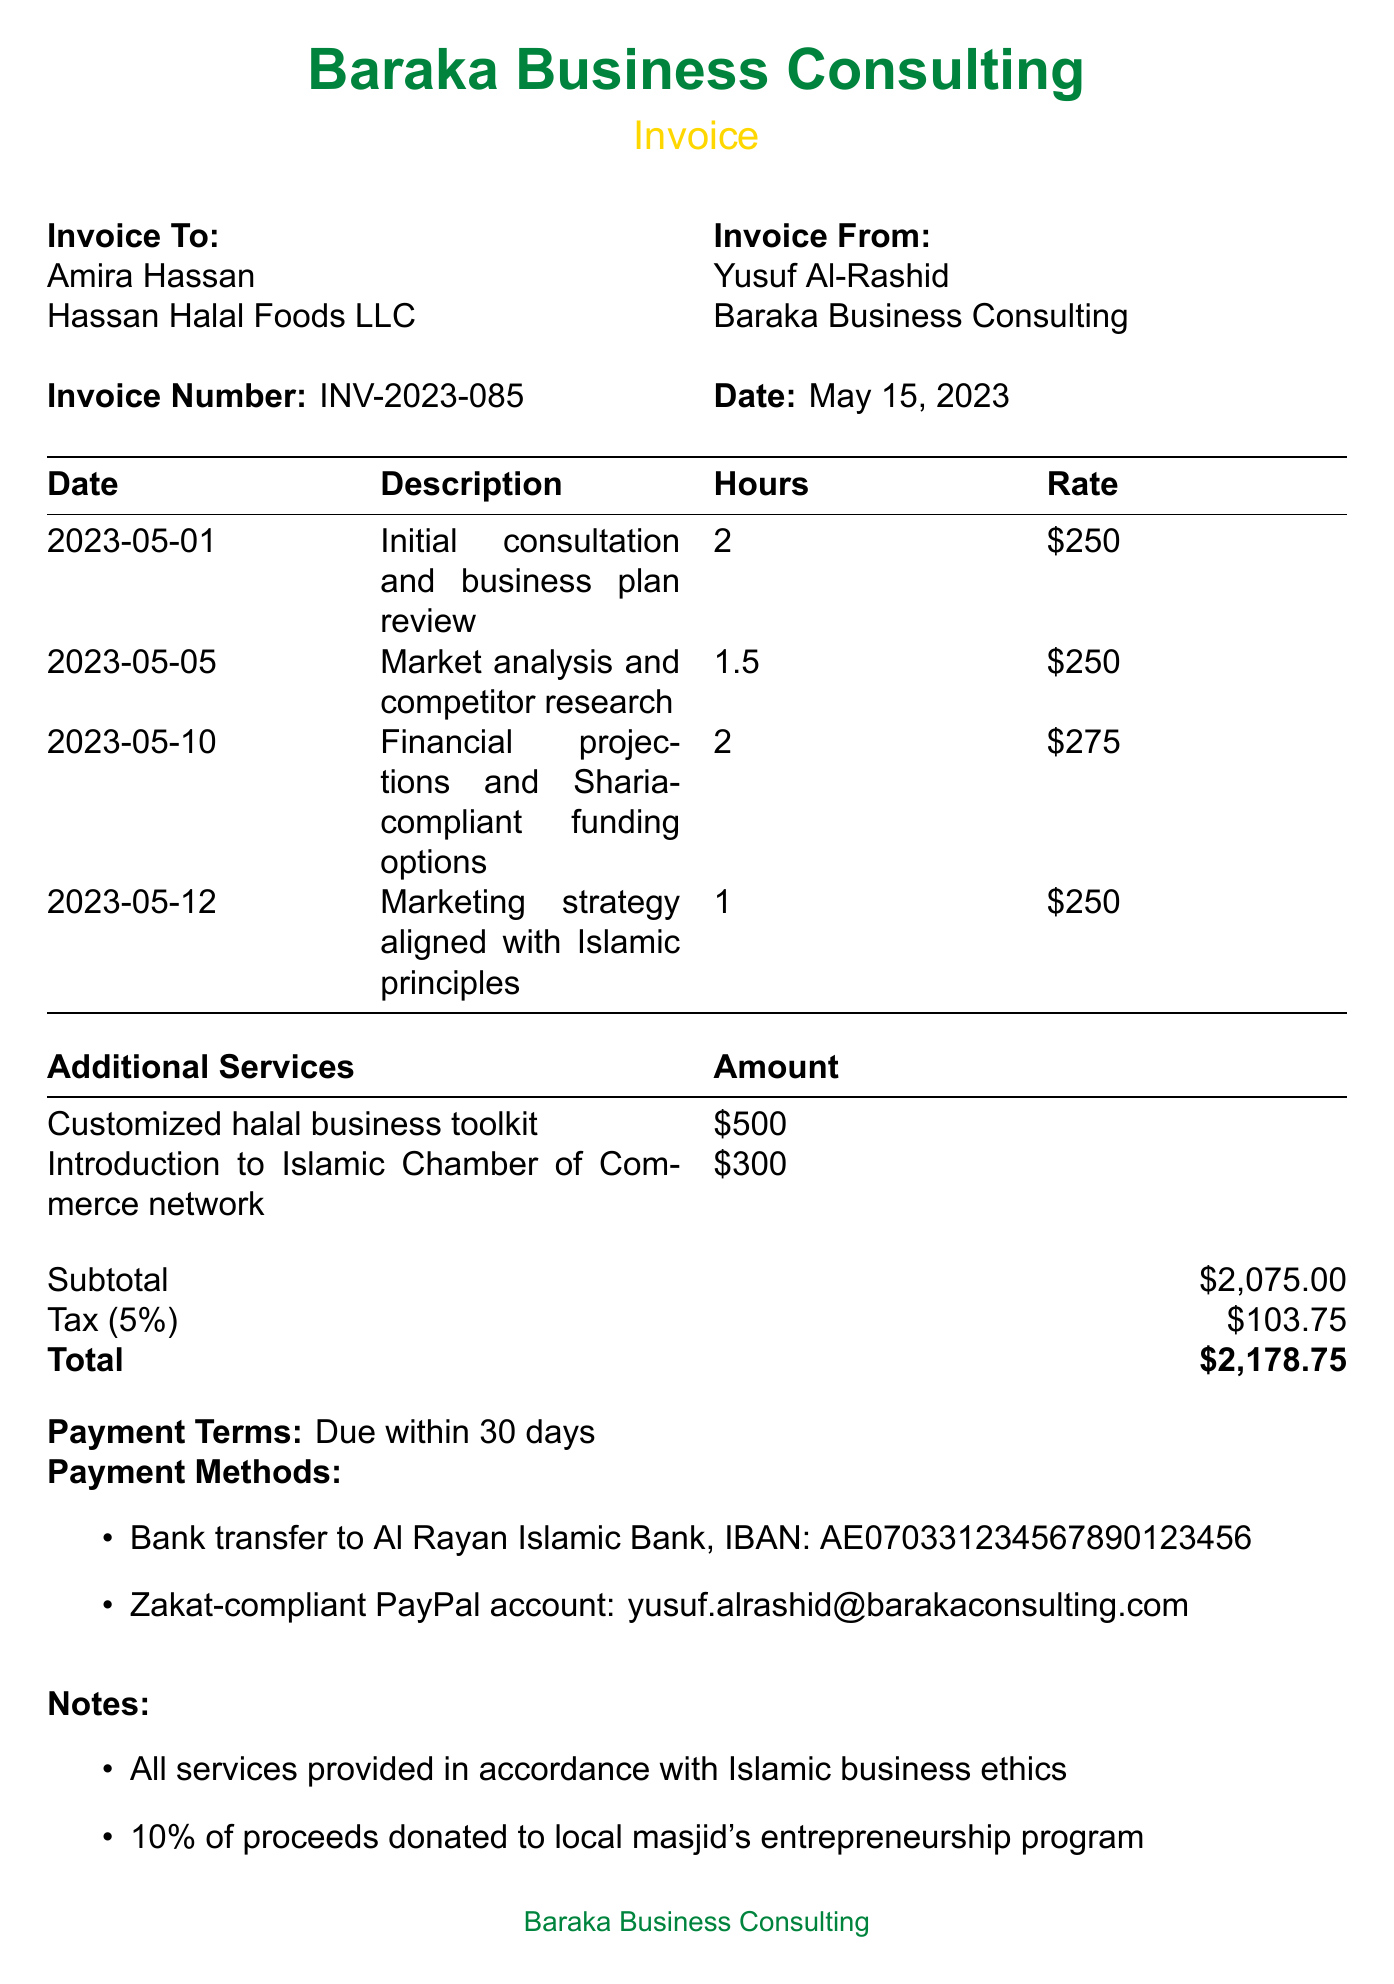What is the invoice number? The invoice number is found in the header of the document, labeled as the invoice number.
Answer: INV-2023-085 Who is the consultant? The consultant's name is listed near the top of the document, under the "Invoice From" section.
Answer: Yusuf Al-Rashid What was the date of the initial consultation? The date of the initial consultation is provided in the sessions table, under the corresponding description.
Answer: 2023-05-01 What is the hourly rate for financial projections session? The hourly rate for the session is indicated in the sessions table next to the description of that specific service.
Answer: 275 What are the payment terms? The payment terms are clearly outlined in the "Payment Terms" section of the document.
Answer: Due within 30 days What is the total amount due? The total amount due is highlighted at the bottom of the invoice in the summary section.
Answer: 2,178.75 How many hours were spent on market analysis? The number of hours is shown in the sessions table under the relevant description of the service provided.
Answer: 1.5 What percentage of proceeds is donated to the local masjid? The donation percentage is mentioned in the notes section of the invoice.
Answer: 10% What is one of the additional services offered? The additional services section lists several services provided beyond the standard consulting.
Answer: Customized halal business toolkit 